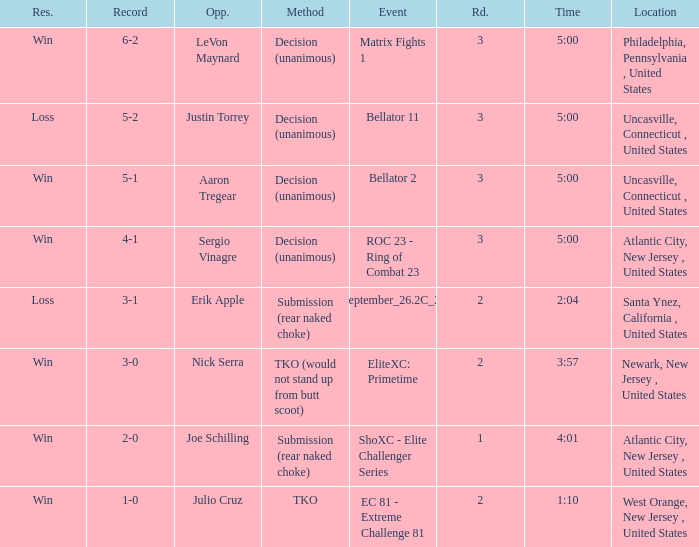During a tko event, who was the opposing party? Julio Cruz. 